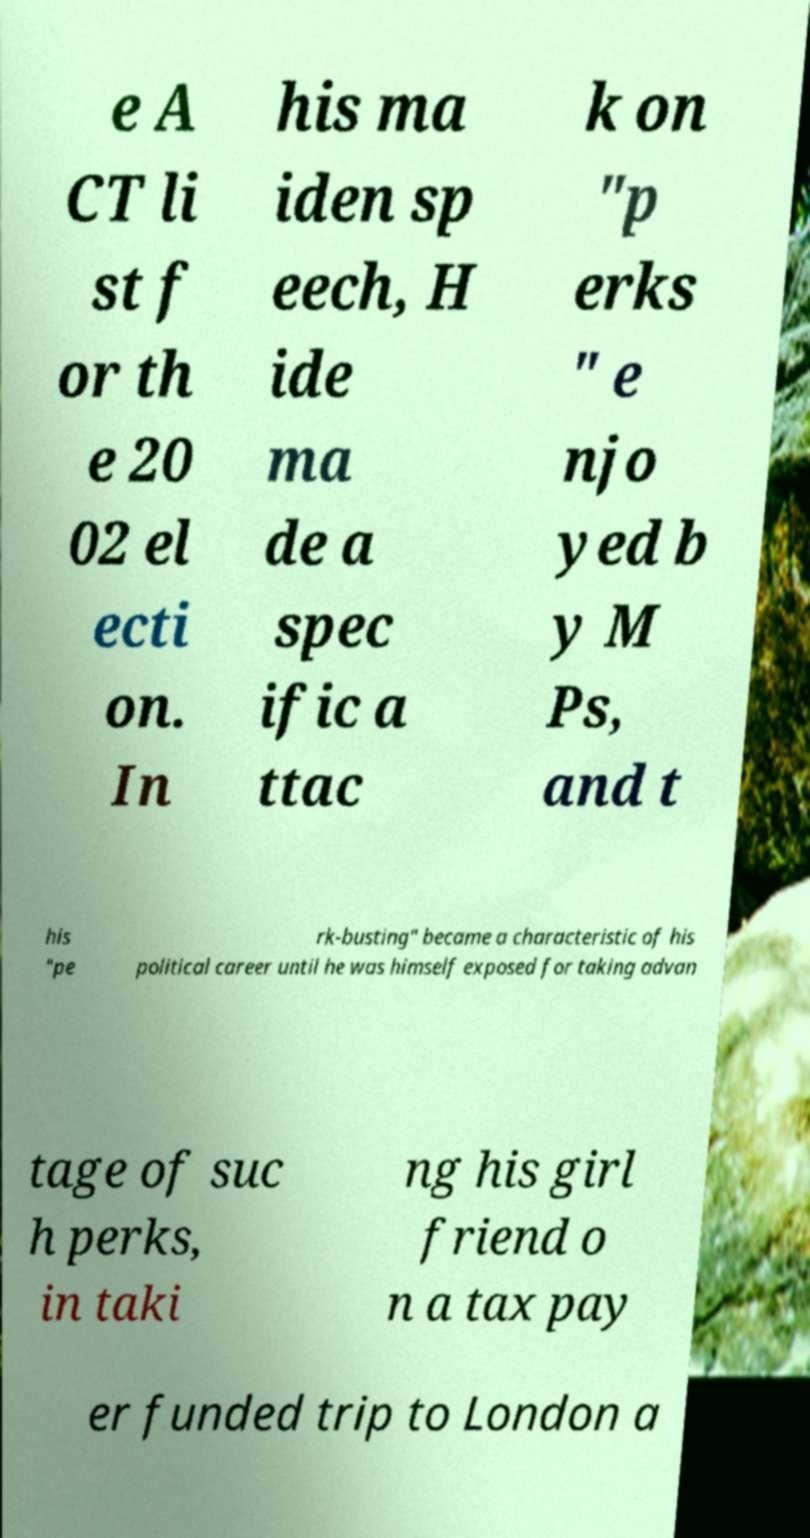Please identify and transcribe the text found in this image. e A CT li st f or th e 20 02 el ecti on. In his ma iden sp eech, H ide ma de a spec ific a ttac k on "p erks " e njo yed b y M Ps, and t his "pe rk-busting" became a characteristic of his political career until he was himself exposed for taking advan tage of suc h perks, in taki ng his girl friend o n a tax pay er funded trip to London a 